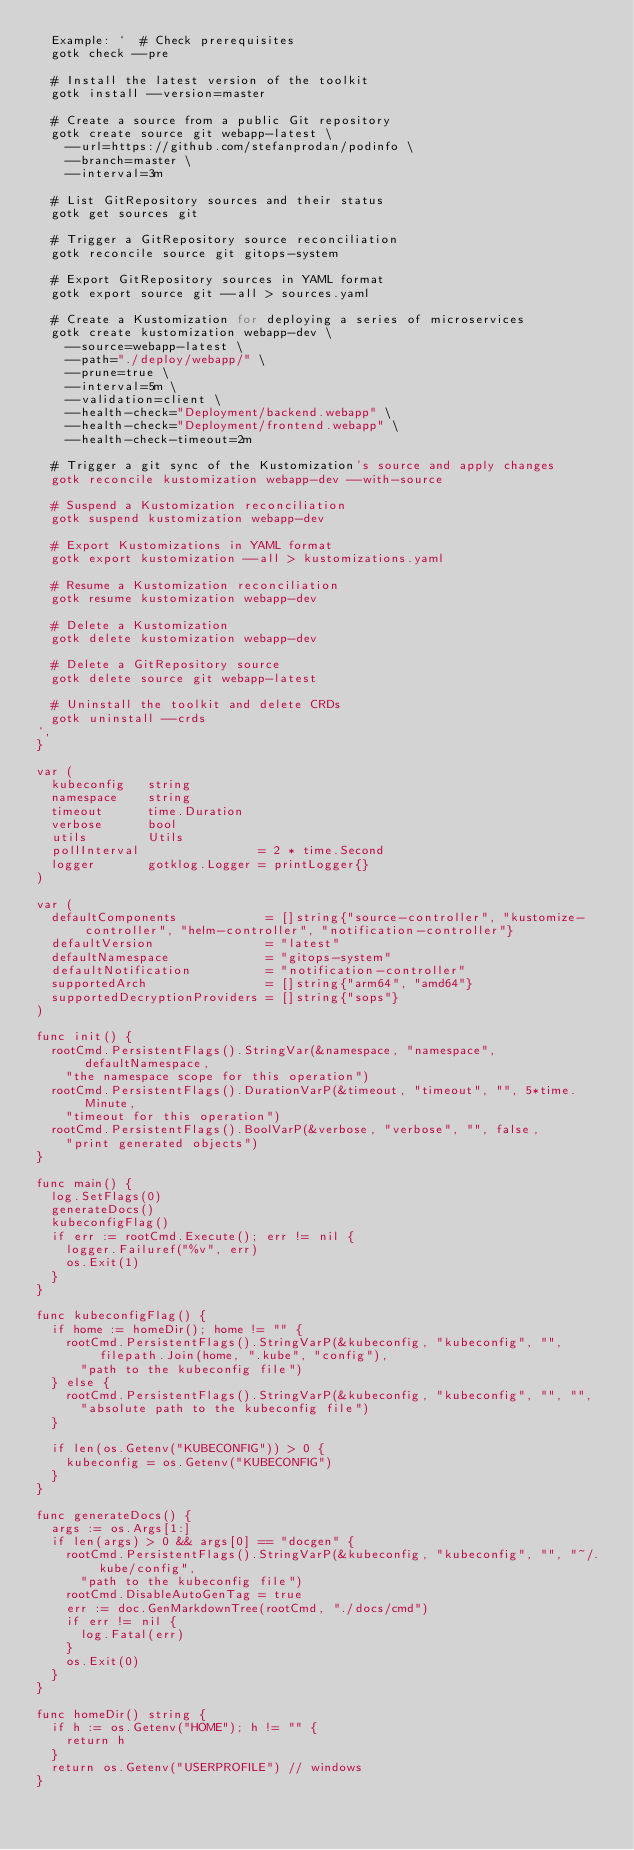<code> <loc_0><loc_0><loc_500><loc_500><_Go_>	Example: `  # Check prerequisites
  gotk check --pre

  # Install the latest version of the toolkit
  gotk install --version=master

  # Create a source from a public Git repository
  gotk create source git webapp-latest \
    --url=https://github.com/stefanprodan/podinfo \
    --branch=master \
    --interval=3m

  # List GitRepository sources and their status
  gotk get sources git

  # Trigger a GitRepository source reconciliation
  gotk reconcile source git gitops-system

  # Export GitRepository sources in YAML format
  gotk export source git --all > sources.yaml

  # Create a Kustomization for deploying a series of microservices
  gotk create kustomization webapp-dev \
    --source=webapp-latest \
    --path="./deploy/webapp/" \
    --prune=true \
    --interval=5m \
    --validation=client \
    --health-check="Deployment/backend.webapp" \
    --health-check="Deployment/frontend.webapp" \
    --health-check-timeout=2m

  # Trigger a git sync of the Kustomization's source and apply changes
  gotk reconcile kustomization webapp-dev --with-source

  # Suspend a Kustomization reconciliation
  gotk suspend kustomization webapp-dev

  # Export Kustomizations in YAML format
  gotk export kustomization --all > kustomizations.yaml

  # Resume a Kustomization reconciliation
  gotk resume kustomization webapp-dev

  # Delete a Kustomization
  gotk delete kustomization webapp-dev

  # Delete a GitRepository source
  gotk delete source git webapp-latest

  # Uninstall the toolkit and delete CRDs
  gotk uninstall --crds
`,
}

var (
	kubeconfig   string
	namespace    string
	timeout      time.Duration
	verbose      bool
	utils        Utils
	pollInterval                = 2 * time.Second
	logger       gotklog.Logger = printLogger{}
)

var (
	defaultComponents            = []string{"source-controller", "kustomize-controller", "helm-controller", "notification-controller"}
	defaultVersion               = "latest"
	defaultNamespace             = "gitops-system"
	defaultNotification          = "notification-controller"
	supportedArch                = []string{"arm64", "amd64"}
	supportedDecryptionProviders = []string{"sops"}
)

func init() {
	rootCmd.PersistentFlags().StringVar(&namespace, "namespace", defaultNamespace,
		"the namespace scope for this operation")
	rootCmd.PersistentFlags().DurationVarP(&timeout, "timeout", "", 5*time.Minute,
		"timeout for this operation")
	rootCmd.PersistentFlags().BoolVarP(&verbose, "verbose", "", false,
		"print generated objects")
}

func main() {
	log.SetFlags(0)
	generateDocs()
	kubeconfigFlag()
	if err := rootCmd.Execute(); err != nil {
		logger.Failuref("%v", err)
		os.Exit(1)
	}
}

func kubeconfigFlag() {
	if home := homeDir(); home != "" {
		rootCmd.PersistentFlags().StringVarP(&kubeconfig, "kubeconfig", "", filepath.Join(home, ".kube", "config"),
			"path to the kubeconfig file")
	} else {
		rootCmd.PersistentFlags().StringVarP(&kubeconfig, "kubeconfig", "", "",
			"absolute path to the kubeconfig file")
	}

	if len(os.Getenv("KUBECONFIG")) > 0 {
		kubeconfig = os.Getenv("KUBECONFIG")
	}
}

func generateDocs() {
	args := os.Args[1:]
	if len(args) > 0 && args[0] == "docgen" {
		rootCmd.PersistentFlags().StringVarP(&kubeconfig, "kubeconfig", "", "~/.kube/config",
			"path to the kubeconfig file")
		rootCmd.DisableAutoGenTag = true
		err := doc.GenMarkdownTree(rootCmd, "./docs/cmd")
		if err != nil {
			log.Fatal(err)
		}
		os.Exit(0)
	}
}

func homeDir() string {
	if h := os.Getenv("HOME"); h != "" {
		return h
	}
	return os.Getenv("USERPROFILE") // windows
}
</code> 